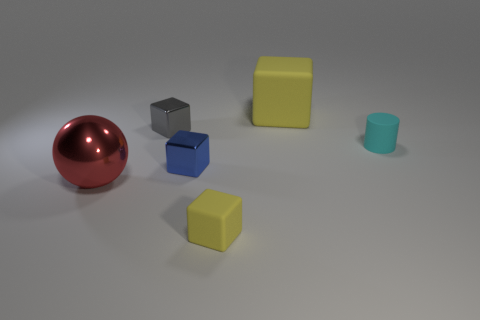Add 2 big blue shiny spheres. How many objects exist? 8 Subtract all balls. How many objects are left? 5 Add 6 green matte cubes. How many green matte cubes exist? 6 Subtract 1 gray blocks. How many objects are left? 5 Subtract all red metallic balls. Subtract all tiny gray blocks. How many objects are left? 4 Add 6 tiny yellow rubber objects. How many tiny yellow rubber objects are left? 7 